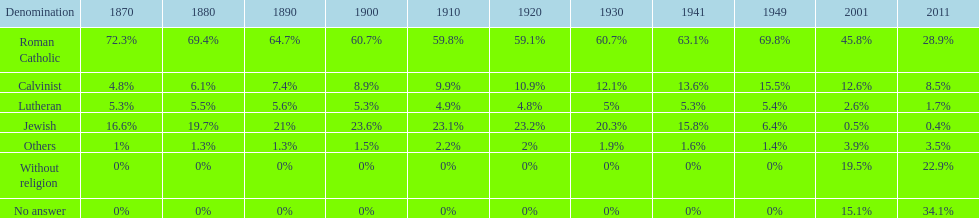Which denomination held the largest percentage in 1880? Roman Catholic. 